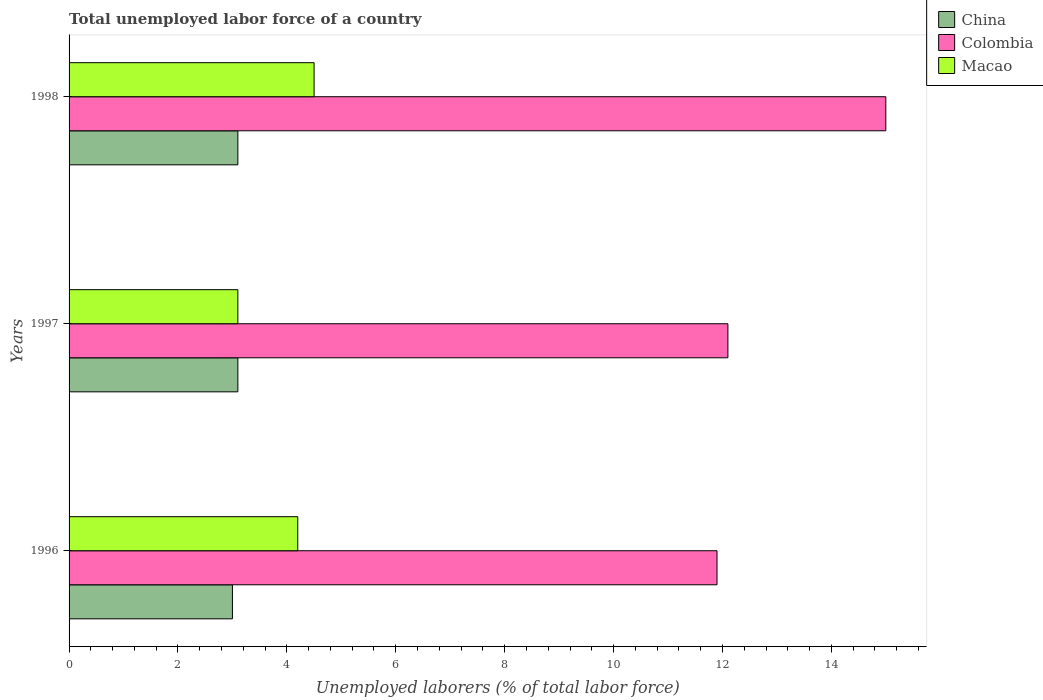How many groups of bars are there?
Your response must be concise. 3. Are the number of bars on each tick of the Y-axis equal?
Offer a very short reply. Yes. How many bars are there on the 2nd tick from the top?
Your response must be concise. 3. How many bars are there on the 3rd tick from the bottom?
Your answer should be very brief. 3. What is the total unemployed labor force in China in 1996?
Keep it short and to the point. 3. Across all years, what is the minimum total unemployed labor force in China?
Keep it short and to the point. 3. In which year was the total unemployed labor force in Macao maximum?
Provide a succinct answer. 1998. What is the total total unemployed labor force in Macao in the graph?
Offer a very short reply. 11.8. What is the difference between the total unemployed labor force in Macao in 1996 and that in 1998?
Your answer should be compact. -0.3. What is the difference between the total unemployed labor force in Colombia in 1996 and the total unemployed labor force in Macao in 1998?
Ensure brevity in your answer.  7.4. What is the average total unemployed labor force in China per year?
Your answer should be very brief. 3.07. In the year 1998, what is the difference between the total unemployed labor force in Macao and total unemployed labor force in Colombia?
Offer a very short reply. -10.5. What is the ratio of the total unemployed labor force in Colombia in 1996 to that in 1998?
Ensure brevity in your answer.  0.79. Is the difference between the total unemployed labor force in Macao in 1996 and 1997 greater than the difference between the total unemployed labor force in Colombia in 1996 and 1997?
Provide a succinct answer. Yes. What is the difference between the highest and the second highest total unemployed labor force in Macao?
Ensure brevity in your answer.  0.3. What is the difference between the highest and the lowest total unemployed labor force in China?
Keep it short and to the point. 0.1. What does the 3rd bar from the top in 1996 represents?
Your response must be concise. China. What does the 3rd bar from the bottom in 1996 represents?
Your response must be concise. Macao. Is it the case that in every year, the sum of the total unemployed labor force in China and total unemployed labor force in Macao is greater than the total unemployed labor force in Colombia?
Provide a succinct answer. No. Are all the bars in the graph horizontal?
Your answer should be very brief. Yes. Where does the legend appear in the graph?
Keep it short and to the point. Top right. How many legend labels are there?
Your answer should be compact. 3. How are the legend labels stacked?
Offer a terse response. Vertical. What is the title of the graph?
Ensure brevity in your answer.  Total unemployed labor force of a country. What is the label or title of the X-axis?
Provide a succinct answer. Unemployed laborers (% of total labor force). What is the label or title of the Y-axis?
Provide a short and direct response. Years. What is the Unemployed laborers (% of total labor force) in Colombia in 1996?
Your answer should be very brief. 11.9. What is the Unemployed laborers (% of total labor force) in Macao in 1996?
Your answer should be very brief. 4.2. What is the Unemployed laborers (% of total labor force) of China in 1997?
Your response must be concise. 3.1. What is the Unemployed laborers (% of total labor force) of Colombia in 1997?
Keep it short and to the point. 12.1. What is the Unemployed laborers (% of total labor force) in Macao in 1997?
Keep it short and to the point. 3.1. What is the Unemployed laborers (% of total labor force) of China in 1998?
Offer a terse response. 3.1. What is the Unemployed laborers (% of total labor force) of Colombia in 1998?
Offer a very short reply. 15. Across all years, what is the maximum Unemployed laborers (% of total labor force) of China?
Give a very brief answer. 3.1. Across all years, what is the minimum Unemployed laborers (% of total labor force) in Colombia?
Your response must be concise. 11.9. Across all years, what is the minimum Unemployed laborers (% of total labor force) of Macao?
Keep it short and to the point. 3.1. What is the total Unemployed laborers (% of total labor force) in Macao in the graph?
Offer a very short reply. 11.8. What is the difference between the Unemployed laborers (% of total labor force) of Colombia in 1996 and that in 1997?
Your answer should be very brief. -0.2. What is the difference between the Unemployed laborers (% of total labor force) of China in 1996 and that in 1998?
Make the answer very short. -0.1. What is the difference between the Unemployed laborers (% of total labor force) in Macao in 1996 and that in 1998?
Offer a very short reply. -0.3. What is the difference between the Unemployed laborers (% of total labor force) in Colombia in 1997 and that in 1998?
Offer a terse response. -2.9. What is the difference between the Unemployed laborers (% of total labor force) in China in 1996 and the Unemployed laborers (% of total labor force) in Colombia in 1998?
Keep it short and to the point. -12. What is the difference between the Unemployed laborers (% of total labor force) in Colombia in 1996 and the Unemployed laborers (% of total labor force) in Macao in 1998?
Offer a terse response. 7.4. What is the average Unemployed laborers (% of total labor force) in China per year?
Make the answer very short. 3.07. What is the average Unemployed laborers (% of total labor force) of Macao per year?
Offer a terse response. 3.93. In the year 1996, what is the difference between the Unemployed laborers (% of total labor force) of China and Unemployed laborers (% of total labor force) of Colombia?
Keep it short and to the point. -8.9. In the year 1996, what is the difference between the Unemployed laborers (% of total labor force) of Colombia and Unemployed laborers (% of total labor force) of Macao?
Your response must be concise. 7.7. In the year 1997, what is the difference between the Unemployed laborers (% of total labor force) in Colombia and Unemployed laborers (% of total labor force) in Macao?
Give a very brief answer. 9. What is the ratio of the Unemployed laborers (% of total labor force) of China in 1996 to that in 1997?
Offer a terse response. 0.97. What is the ratio of the Unemployed laborers (% of total labor force) in Colombia in 1996 to that in 1997?
Offer a very short reply. 0.98. What is the ratio of the Unemployed laborers (% of total labor force) in Macao in 1996 to that in 1997?
Offer a very short reply. 1.35. What is the ratio of the Unemployed laborers (% of total labor force) in China in 1996 to that in 1998?
Ensure brevity in your answer.  0.97. What is the ratio of the Unemployed laborers (% of total labor force) in Colombia in 1996 to that in 1998?
Make the answer very short. 0.79. What is the ratio of the Unemployed laborers (% of total labor force) of Macao in 1996 to that in 1998?
Provide a succinct answer. 0.93. What is the ratio of the Unemployed laborers (% of total labor force) of Colombia in 1997 to that in 1998?
Offer a terse response. 0.81. What is the ratio of the Unemployed laborers (% of total labor force) of Macao in 1997 to that in 1998?
Keep it short and to the point. 0.69. What is the difference between the highest and the second highest Unemployed laborers (% of total labor force) in China?
Keep it short and to the point. 0. What is the difference between the highest and the second highest Unemployed laborers (% of total labor force) in Macao?
Keep it short and to the point. 0.3. 